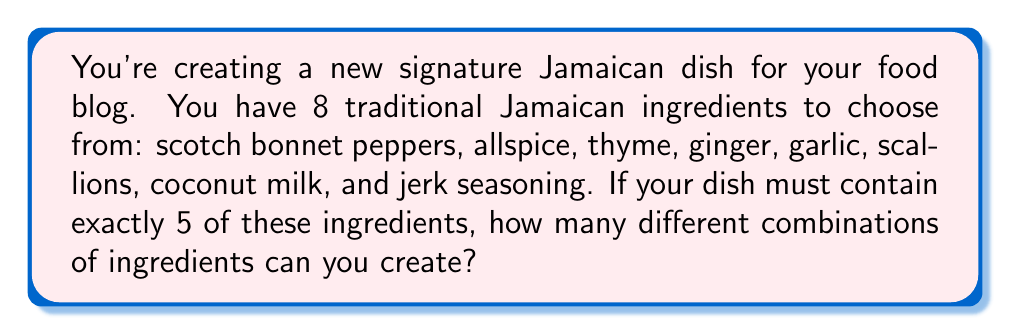Can you answer this question? Let's approach this step-by-step:

1) This is a combination problem. We're selecting 5 ingredients from a total of 8, where the order doesn't matter.

2) The formula for combinations is:

   $$C(n,r) = \frac{n!}{r!(n-r)!}$$

   Where $n$ is the total number of items to choose from, and $r$ is the number of items being chosen.

3) In this case, $n = 8$ (total ingredients) and $r = 5$ (ingredients in each dish).

4) Let's substitute these values into our formula:

   $$C(8,5) = \frac{8!}{5!(8-5)!} = \frac{8!}{5!(3)!}$$

5) Expand this:
   $$\frac{8 * 7 * 6 * 5!}{5! * 3 * 2 * 1}$$

6) The 5! cancels out in the numerator and denominator:

   $$\frac{8 * 7 * 6}{3 * 2 * 1} = \frac{336}{6}$$

7) Simplify:
   $$336 \div 6 = 56$$

Therefore, there are 56 different possible combinations of 5 ingredients that can be chosen from the 8 available ingredients.
Answer: 56 